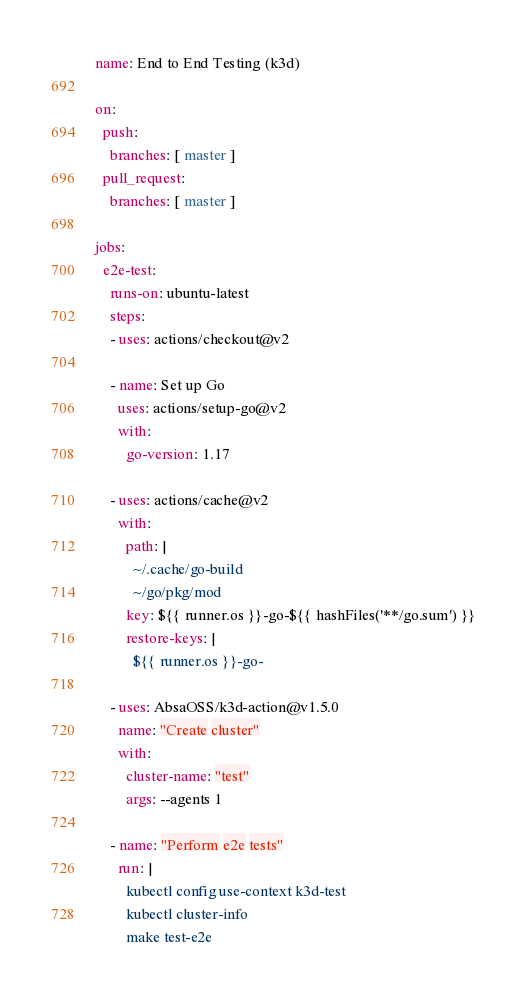<code> <loc_0><loc_0><loc_500><loc_500><_YAML_>name: End to End Testing (k3d)

on:
  push:
    branches: [ master ]
  pull_request:
    branches: [ master ]

jobs:
  e2e-test:
    runs-on: ubuntu-latest
    steps:
    - uses: actions/checkout@v2
    
    - name: Set up Go
      uses: actions/setup-go@v2
      with:
        go-version: 1.17
    
    - uses: actions/cache@v2
      with:
        path: |
          ~/.cache/go-build
          ~/go/pkg/mod
        key: ${{ runner.os }}-go-${{ hashFiles('**/go.sum') }}
        restore-keys: |
          ${{ runner.os }}-go-
   
    - uses: AbsaOSS/k3d-action@v1.5.0
      name: "Create cluster"
      with:
        cluster-name: "test"
        args: --agents 1

    - name: "Perform e2e tests"
      run: |
        kubectl config use-context k3d-test
        kubectl cluster-info
        make test-e2e
</code> 